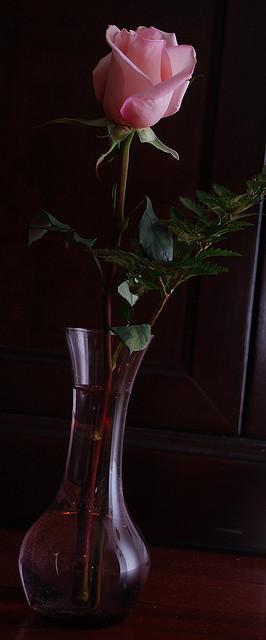Is the flower in a vase?
Answer briefly. Yes. How many flowers are there?
Be succinct. 1. What color is the flower?
Answer briefly. Pink. 